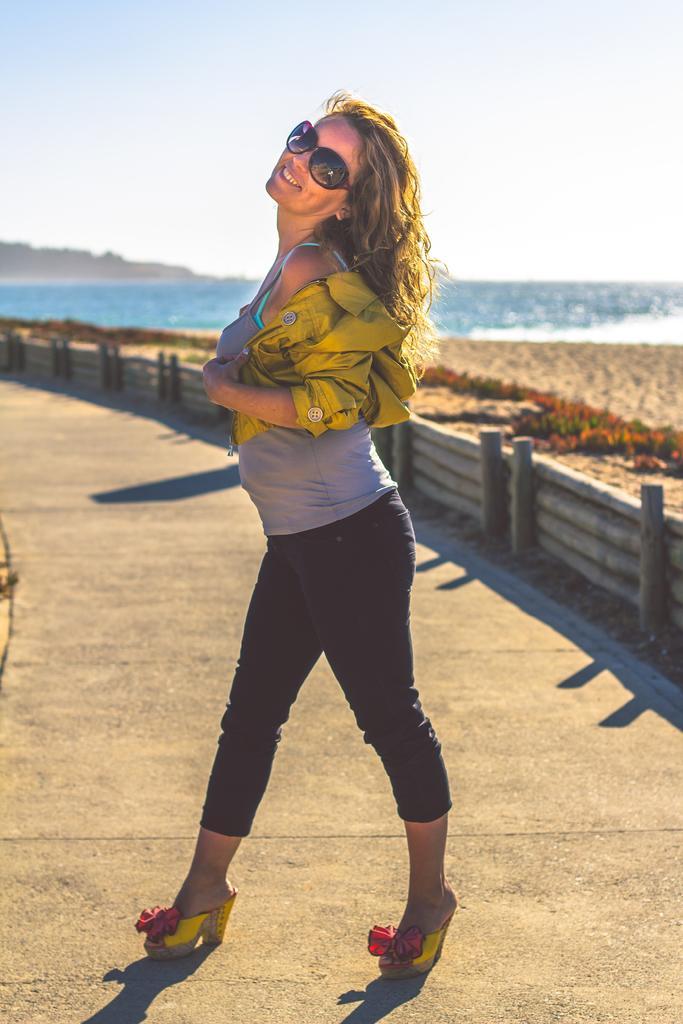In one or two sentences, can you explain what this image depicts? In this picture I can see there is a woman standing wearing a green color coat and she is standing here on the walk way and in the backdrop there is a beach, sand and a ocean and a mountain. The sky is clear. 